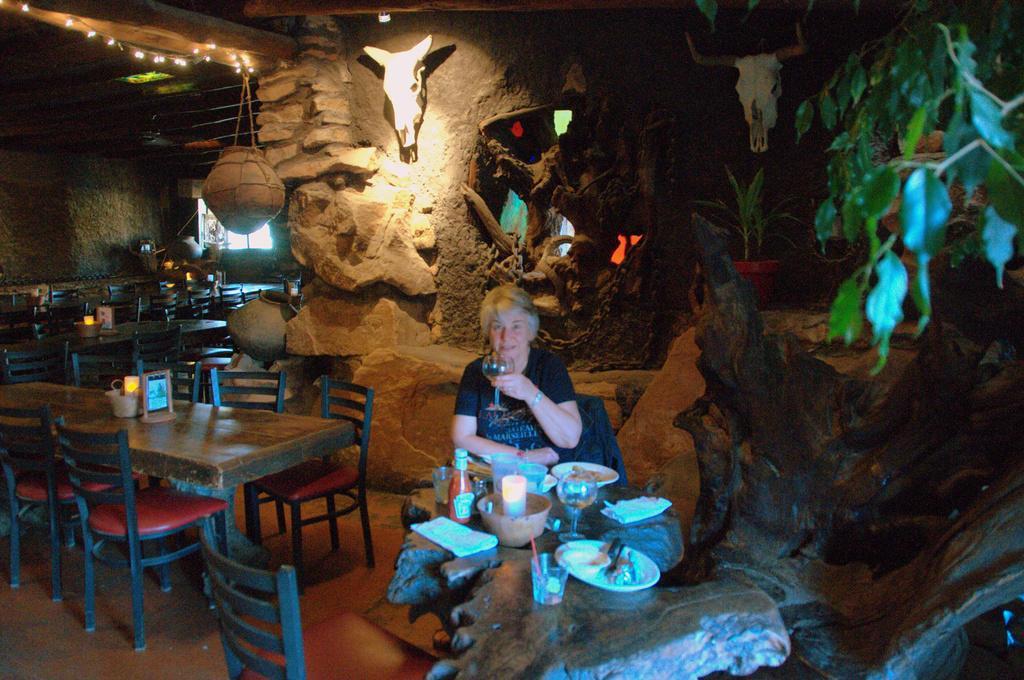Please provide a concise description of this image. I think this picture is taken in a cave. In the cave, there are tables surrounded by the chairs. In the center, there is a woman holding a glass. Before her there is a tree trunk. On the trunk, there are plates, bowls, glasses were placed. In the background there are statues of animal heads. Towards the right, there is a plant. 